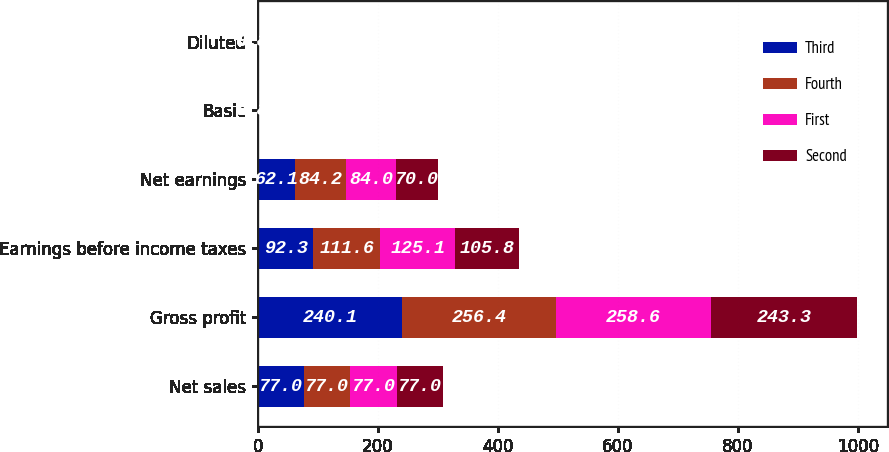Convert chart. <chart><loc_0><loc_0><loc_500><loc_500><stacked_bar_chart><ecel><fcel>Net sales<fcel>Gross profit<fcel>Earnings before income taxes<fcel>Net earnings<fcel>Basic<fcel>Diluted<nl><fcel>Third<fcel>77<fcel>240.1<fcel>92.3<fcel>62.1<fcel>0.33<fcel>0.33<nl><fcel>Fourth<fcel>77<fcel>256.4<fcel>111.6<fcel>84.2<fcel>0.45<fcel>0.45<nl><fcel>First<fcel>77<fcel>258.6<fcel>125.1<fcel>84<fcel>0.45<fcel>0.45<nl><fcel>Second<fcel>77<fcel>243.3<fcel>105.8<fcel>70<fcel>0.38<fcel>0.38<nl></chart> 